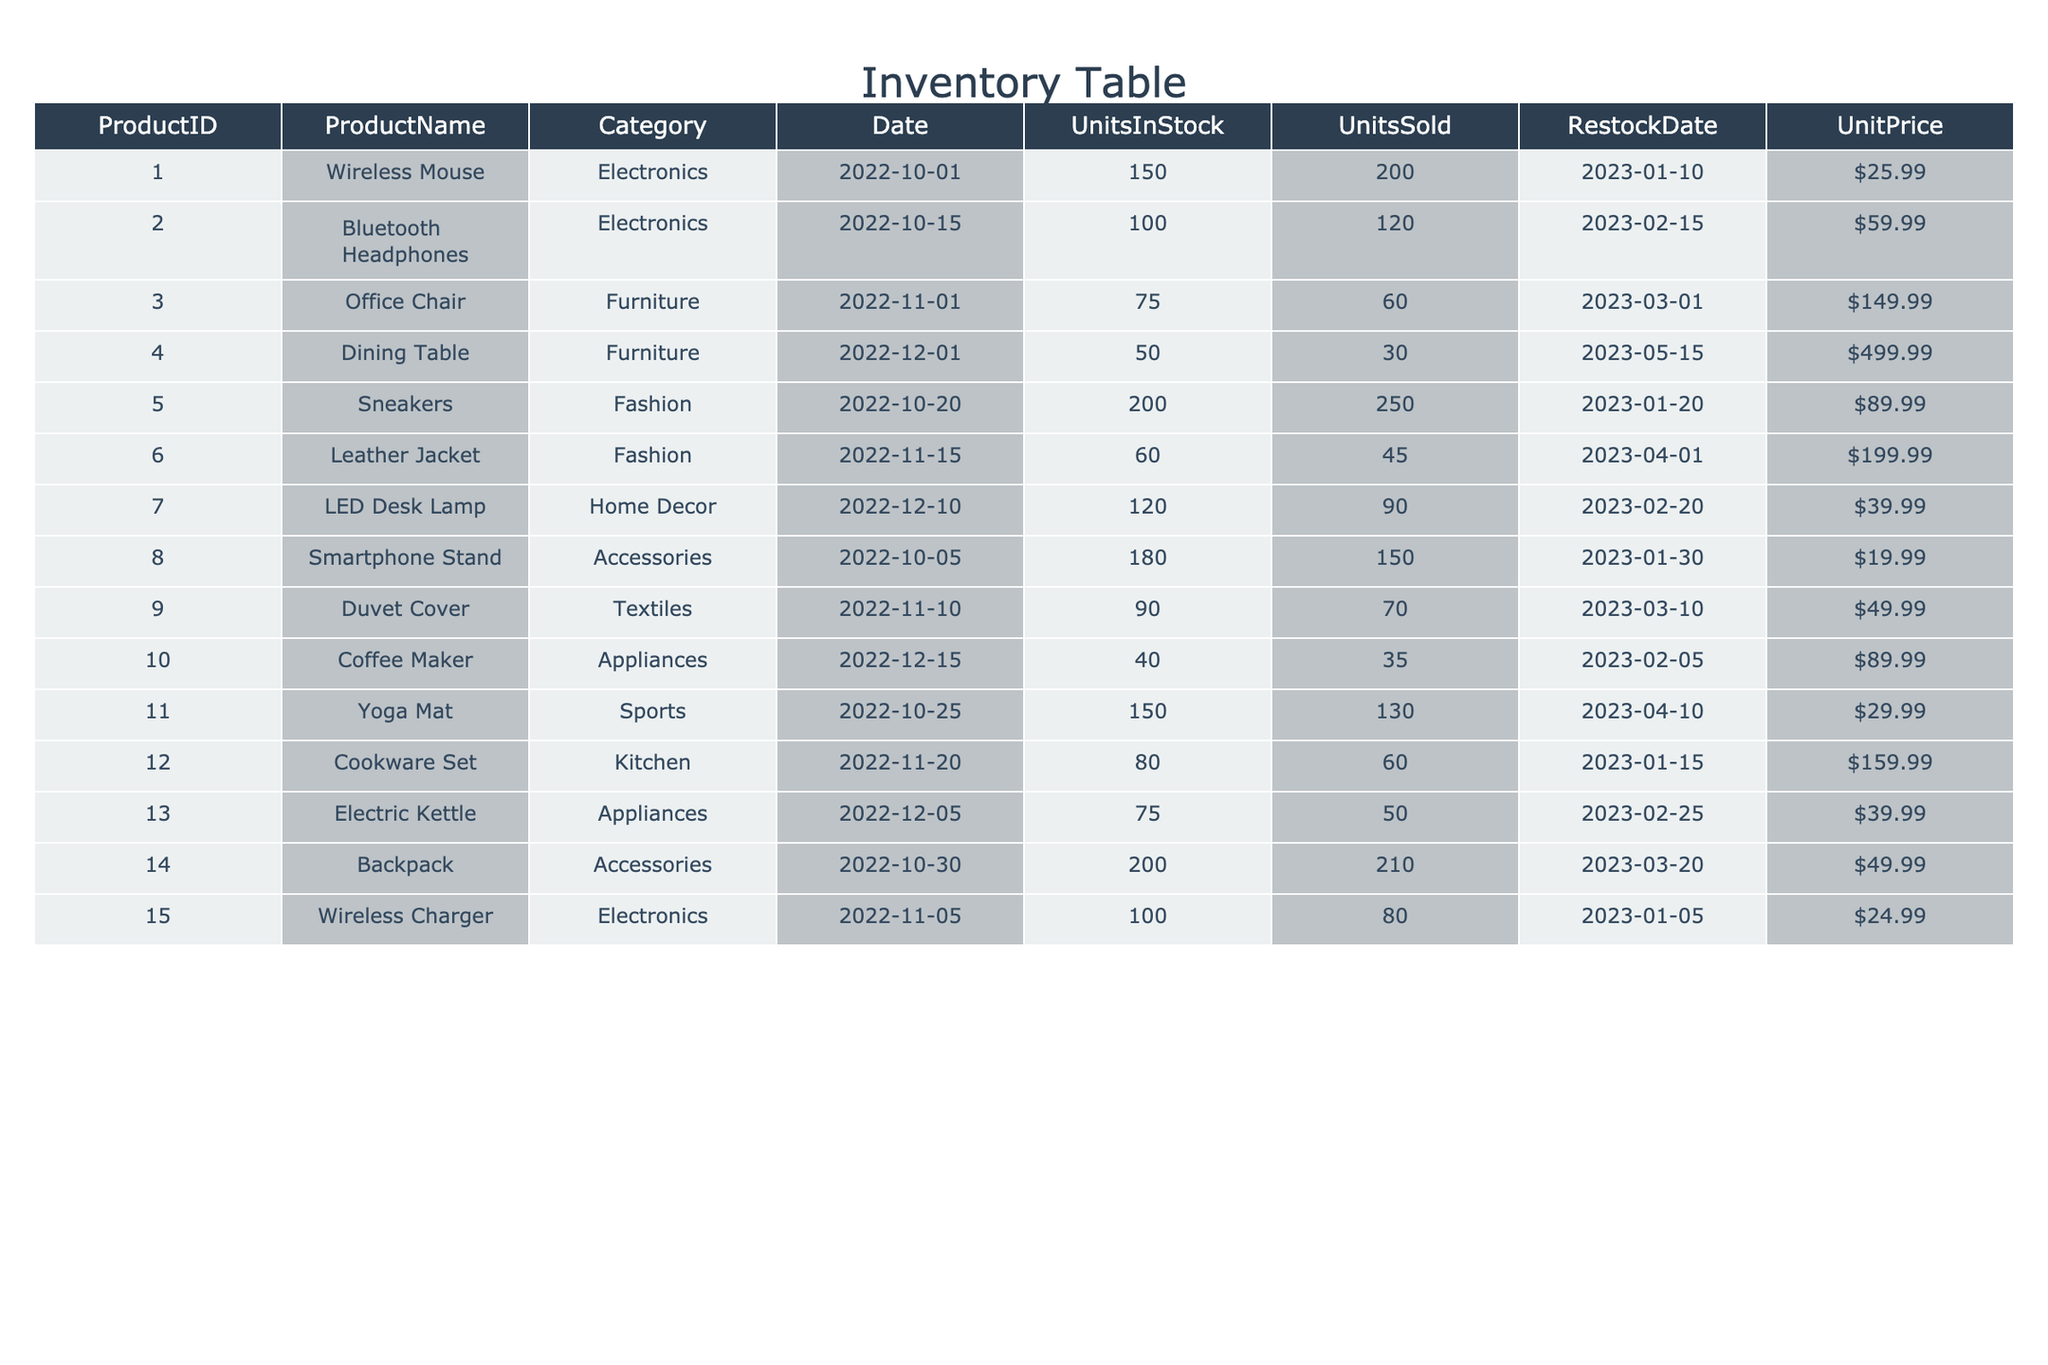What is the Unit Price of the Wireless Mouse? The Unit Price for the Wireless Mouse can be found in the 'UnitPrice' column of the row where 'ProductName' is 'Wireless Mouse'. It states 25.99.
Answer: 25.99 Which product category has the highest Units Sold? To determine the product category with the highest Units Sold, we compare the 'UnitsSold' values across all rows. The Fashion category (particularly Sneakers) shows the highest individual sales of 250.
Answer: Fashion What is the total number of Units in Stock for all Electronics products? To find the total Units in Stock for Electronics, I sum the 'UnitsInStock' values from the Electronics category: Wireless Mouse (150) + Bluetooth Headphones (100) + Wireless Charger (100) = 350.
Answer: 350 Did any product run out of stock based on the data? A product runs out of stock if its UnitsInStock is less than or equal to zero after considering UnitsSold. By examining the data, no product has a negative UnitsInStock, meaning none have run out of stock.
Answer: No What is the average Unit Price of the Furniture category? To calculate the average Unit Price for Furniture, we add the Unit Prices for 'Office Chair' (149.99) and 'Dining Table' (499.99), which totals 649.98, and then divide by the number of Furniture products (2), giving an average of 324.99.
Answer: 324.99 Which product had the earliest Restock Date? By reviewing the 'RestockDate' column, the product with the earliest Restock Date is the Wireless Charger, which restocked on 2023-01-05.
Answer: Wireless Charger How many total Units Sold does the Accessories category have? The total Units Sold for Accessories are summed from the rows for 'Smartphone Stand' (150) and 'Backpack' (210), which is 150 + 210 = 360.
Answer: 360 Can we find a product that sold more than 100 units and required restocking after January 1, 2023? By checking the 'UnitsSold' column and the 'RestockDate', both Wireless Mouse (200 sold) and Backpack (210 sold) meet this criterion as their restock dates fall after January 1, 2023.
Answer: Yes What was the restock date for the Duvet Cover? The restock date for the Duvet Cover is listed in the 'RestockDate' column, which shows as 2023-03-10.
Answer: 2023-03-10 